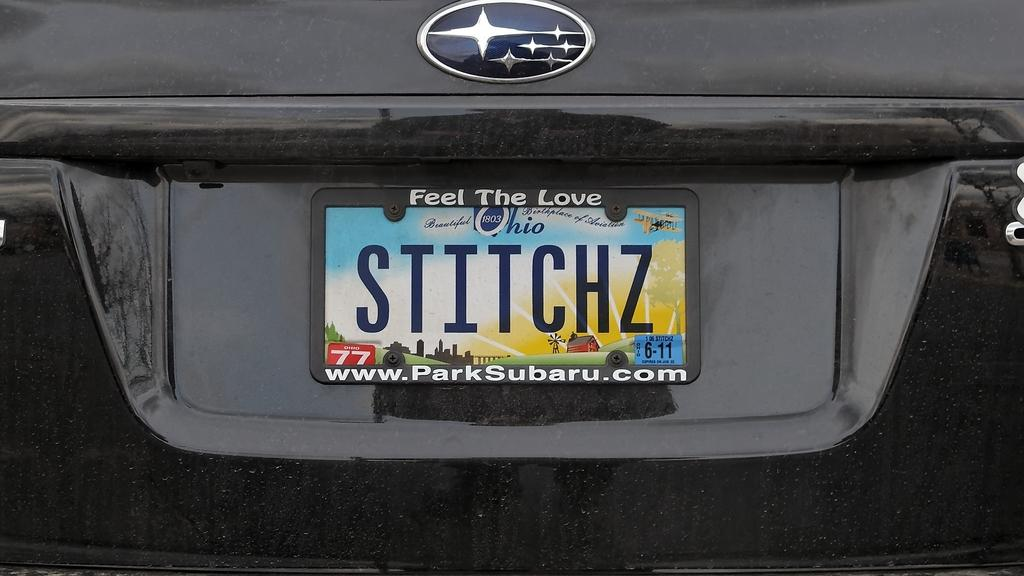Provide a one-sentence caption for the provided image. The license plate is from the state of Ohio. 